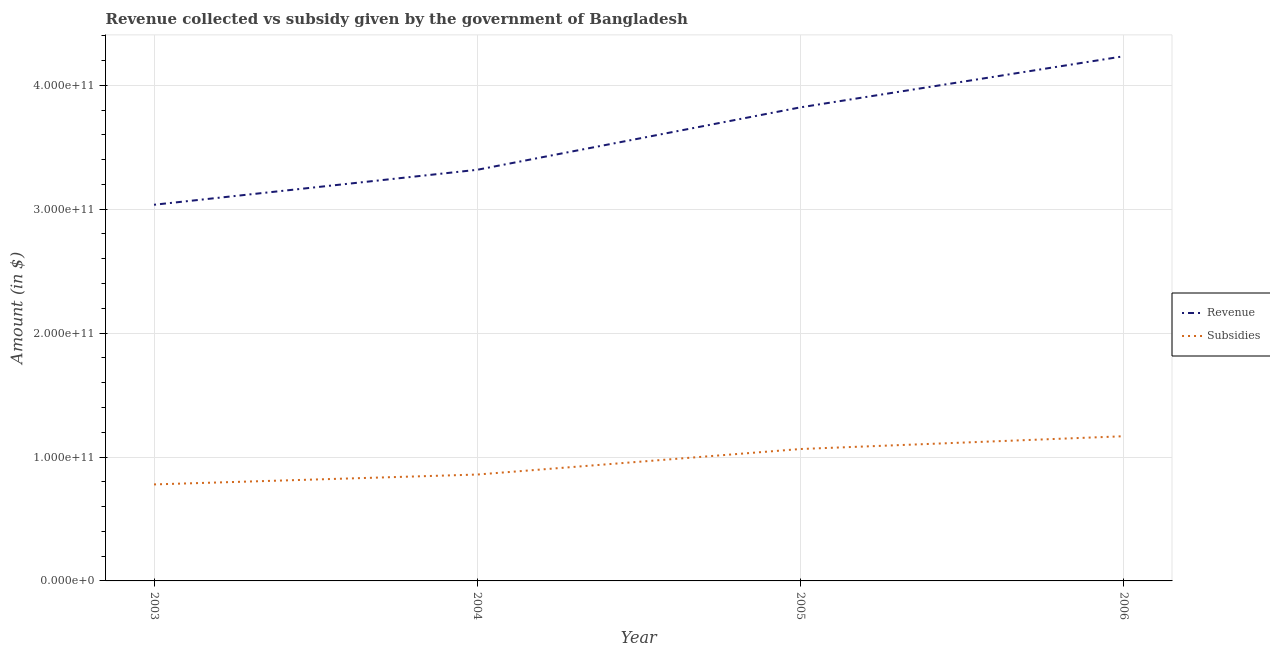Does the line corresponding to amount of revenue collected intersect with the line corresponding to amount of subsidies given?
Provide a short and direct response. No. Is the number of lines equal to the number of legend labels?
Give a very brief answer. Yes. What is the amount of subsidies given in 2006?
Give a very brief answer. 1.17e+11. Across all years, what is the maximum amount of revenue collected?
Ensure brevity in your answer.  4.23e+11. Across all years, what is the minimum amount of subsidies given?
Provide a succinct answer. 7.79e+1. In which year was the amount of subsidies given maximum?
Your response must be concise. 2006. What is the total amount of revenue collected in the graph?
Ensure brevity in your answer.  1.44e+12. What is the difference between the amount of subsidies given in 2005 and that in 2006?
Provide a short and direct response. -1.03e+1. What is the difference between the amount of revenue collected in 2006 and the amount of subsidies given in 2004?
Provide a short and direct response. 3.38e+11. What is the average amount of revenue collected per year?
Provide a short and direct response. 3.60e+11. In the year 2003, what is the difference between the amount of subsidies given and amount of revenue collected?
Your response must be concise. -2.26e+11. What is the ratio of the amount of subsidies given in 2003 to that in 2004?
Provide a succinct answer. 0.91. Is the difference between the amount of subsidies given in 2005 and 2006 greater than the difference between the amount of revenue collected in 2005 and 2006?
Provide a short and direct response. Yes. What is the difference between the highest and the second highest amount of subsidies given?
Give a very brief answer. 1.03e+1. What is the difference between the highest and the lowest amount of subsidies given?
Give a very brief answer. 3.89e+1. Does the amount of revenue collected monotonically increase over the years?
Your answer should be very brief. Yes. Is the amount of subsidies given strictly greater than the amount of revenue collected over the years?
Your response must be concise. No. How many lines are there?
Give a very brief answer. 2. What is the difference between two consecutive major ticks on the Y-axis?
Your answer should be compact. 1.00e+11. Are the values on the major ticks of Y-axis written in scientific E-notation?
Make the answer very short. Yes. Does the graph contain any zero values?
Your response must be concise. No. Where does the legend appear in the graph?
Offer a very short reply. Center right. How many legend labels are there?
Your answer should be compact. 2. How are the legend labels stacked?
Offer a very short reply. Vertical. What is the title of the graph?
Your response must be concise. Revenue collected vs subsidy given by the government of Bangladesh. What is the label or title of the Y-axis?
Provide a succinct answer. Amount (in $). What is the Amount (in $) in Revenue in 2003?
Your answer should be compact. 3.04e+11. What is the Amount (in $) in Subsidies in 2003?
Provide a short and direct response. 7.79e+1. What is the Amount (in $) in Revenue in 2004?
Your answer should be compact. 3.32e+11. What is the Amount (in $) of Subsidies in 2004?
Ensure brevity in your answer.  8.59e+1. What is the Amount (in $) of Revenue in 2005?
Give a very brief answer. 3.82e+11. What is the Amount (in $) of Subsidies in 2005?
Your answer should be very brief. 1.06e+11. What is the Amount (in $) of Revenue in 2006?
Offer a very short reply. 4.23e+11. What is the Amount (in $) of Subsidies in 2006?
Offer a very short reply. 1.17e+11. Across all years, what is the maximum Amount (in $) of Revenue?
Your answer should be compact. 4.23e+11. Across all years, what is the maximum Amount (in $) in Subsidies?
Your answer should be compact. 1.17e+11. Across all years, what is the minimum Amount (in $) of Revenue?
Your response must be concise. 3.04e+11. Across all years, what is the minimum Amount (in $) in Subsidies?
Your answer should be compact. 7.79e+1. What is the total Amount (in $) of Revenue in the graph?
Provide a succinct answer. 1.44e+12. What is the total Amount (in $) of Subsidies in the graph?
Your answer should be compact. 3.87e+11. What is the difference between the Amount (in $) of Revenue in 2003 and that in 2004?
Provide a short and direct response. -2.82e+1. What is the difference between the Amount (in $) in Subsidies in 2003 and that in 2004?
Make the answer very short. -7.98e+09. What is the difference between the Amount (in $) of Revenue in 2003 and that in 2005?
Give a very brief answer. -7.86e+1. What is the difference between the Amount (in $) of Subsidies in 2003 and that in 2005?
Make the answer very short. -2.86e+1. What is the difference between the Amount (in $) of Revenue in 2003 and that in 2006?
Offer a very short reply. -1.20e+11. What is the difference between the Amount (in $) of Subsidies in 2003 and that in 2006?
Provide a short and direct response. -3.89e+1. What is the difference between the Amount (in $) of Revenue in 2004 and that in 2005?
Ensure brevity in your answer.  -5.04e+1. What is the difference between the Amount (in $) in Subsidies in 2004 and that in 2005?
Your answer should be very brief. -2.06e+1. What is the difference between the Amount (in $) of Revenue in 2004 and that in 2006?
Provide a succinct answer. -9.16e+1. What is the difference between the Amount (in $) in Subsidies in 2004 and that in 2006?
Give a very brief answer. -3.09e+1. What is the difference between the Amount (in $) of Revenue in 2005 and that in 2006?
Your answer should be very brief. -4.12e+1. What is the difference between the Amount (in $) in Subsidies in 2005 and that in 2006?
Offer a terse response. -1.03e+1. What is the difference between the Amount (in $) of Revenue in 2003 and the Amount (in $) of Subsidies in 2004?
Your response must be concise. 2.18e+11. What is the difference between the Amount (in $) of Revenue in 2003 and the Amount (in $) of Subsidies in 2005?
Keep it short and to the point. 1.97e+11. What is the difference between the Amount (in $) in Revenue in 2003 and the Amount (in $) in Subsidies in 2006?
Your answer should be very brief. 1.87e+11. What is the difference between the Amount (in $) in Revenue in 2004 and the Amount (in $) in Subsidies in 2005?
Ensure brevity in your answer.  2.25e+11. What is the difference between the Amount (in $) of Revenue in 2004 and the Amount (in $) of Subsidies in 2006?
Give a very brief answer. 2.15e+11. What is the difference between the Amount (in $) in Revenue in 2005 and the Amount (in $) in Subsidies in 2006?
Your answer should be compact. 2.65e+11. What is the average Amount (in $) of Revenue per year?
Offer a very short reply. 3.60e+11. What is the average Amount (in $) in Subsidies per year?
Provide a short and direct response. 9.67e+1. In the year 2003, what is the difference between the Amount (in $) of Revenue and Amount (in $) of Subsidies?
Give a very brief answer. 2.26e+11. In the year 2004, what is the difference between the Amount (in $) of Revenue and Amount (in $) of Subsidies?
Offer a terse response. 2.46e+11. In the year 2005, what is the difference between the Amount (in $) in Revenue and Amount (in $) in Subsidies?
Make the answer very short. 2.76e+11. In the year 2006, what is the difference between the Amount (in $) of Revenue and Amount (in $) of Subsidies?
Your response must be concise. 3.07e+11. What is the ratio of the Amount (in $) of Revenue in 2003 to that in 2004?
Your answer should be very brief. 0.92. What is the ratio of the Amount (in $) in Subsidies in 2003 to that in 2004?
Provide a succinct answer. 0.91. What is the ratio of the Amount (in $) of Revenue in 2003 to that in 2005?
Give a very brief answer. 0.79. What is the ratio of the Amount (in $) in Subsidies in 2003 to that in 2005?
Offer a terse response. 0.73. What is the ratio of the Amount (in $) of Revenue in 2003 to that in 2006?
Offer a very short reply. 0.72. What is the ratio of the Amount (in $) in Subsidies in 2003 to that in 2006?
Keep it short and to the point. 0.67. What is the ratio of the Amount (in $) in Revenue in 2004 to that in 2005?
Ensure brevity in your answer.  0.87. What is the ratio of the Amount (in $) of Subsidies in 2004 to that in 2005?
Provide a short and direct response. 0.81. What is the ratio of the Amount (in $) of Revenue in 2004 to that in 2006?
Offer a very short reply. 0.78. What is the ratio of the Amount (in $) in Subsidies in 2004 to that in 2006?
Your response must be concise. 0.74. What is the ratio of the Amount (in $) in Revenue in 2005 to that in 2006?
Give a very brief answer. 0.9. What is the ratio of the Amount (in $) of Subsidies in 2005 to that in 2006?
Keep it short and to the point. 0.91. What is the difference between the highest and the second highest Amount (in $) of Revenue?
Keep it short and to the point. 4.12e+1. What is the difference between the highest and the second highest Amount (in $) in Subsidies?
Provide a succinct answer. 1.03e+1. What is the difference between the highest and the lowest Amount (in $) in Revenue?
Provide a succinct answer. 1.20e+11. What is the difference between the highest and the lowest Amount (in $) in Subsidies?
Ensure brevity in your answer.  3.89e+1. 